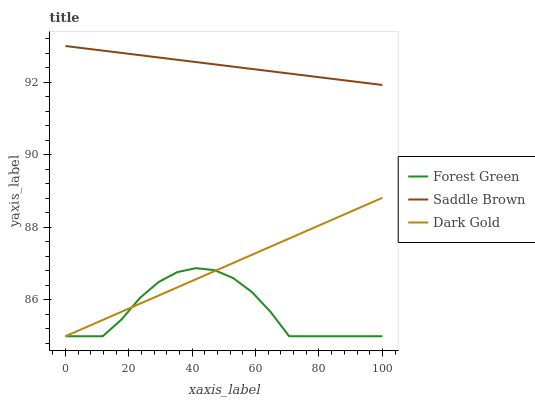Does Forest Green have the minimum area under the curve?
Answer yes or no. Yes. Does Saddle Brown have the maximum area under the curve?
Answer yes or no. Yes. Does Dark Gold have the minimum area under the curve?
Answer yes or no. No. Does Dark Gold have the maximum area under the curve?
Answer yes or no. No. Is Saddle Brown the smoothest?
Answer yes or no. Yes. Is Forest Green the roughest?
Answer yes or no. Yes. Is Dark Gold the smoothest?
Answer yes or no. No. Is Dark Gold the roughest?
Answer yes or no. No. Does Forest Green have the lowest value?
Answer yes or no. Yes. Does Saddle Brown have the lowest value?
Answer yes or no. No. Does Saddle Brown have the highest value?
Answer yes or no. Yes. Does Dark Gold have the highest value?
Answer yes or no. No. Is Dark Gold less than Saddle Brown?
Answer yes or no. Yes. Is Saddle Brown greater than Forest Green?
Answer yes or no. Yes. Does Forest Green intersect Dark Gold?
Answer yes or no. Yes. Is Forest Green less than Dark Gold?
Answer yes or no. No. Is Forest Green greater than Dark Gold?
Answer yes or no. No. Does Dark Gold intersect Saddle Brown?
Answer yes or no. No. 